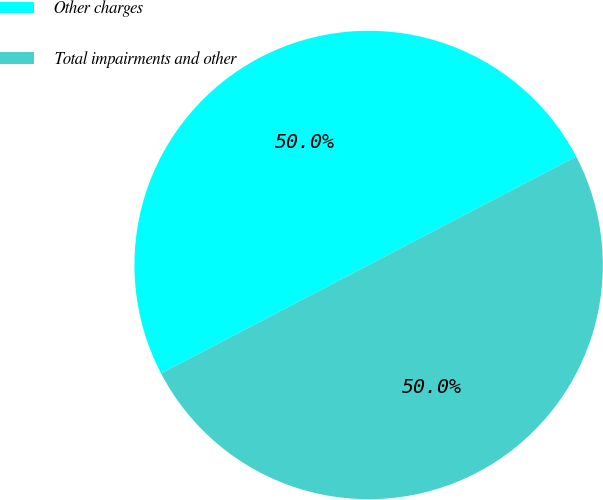<chart> <loc_0><loc_0><loc_500><loc_500><pie_chart><fcel>Other charges<fcel>Total impairments and other<nl><fcel>50.0%<fcel>50.0%<nl></chart> 